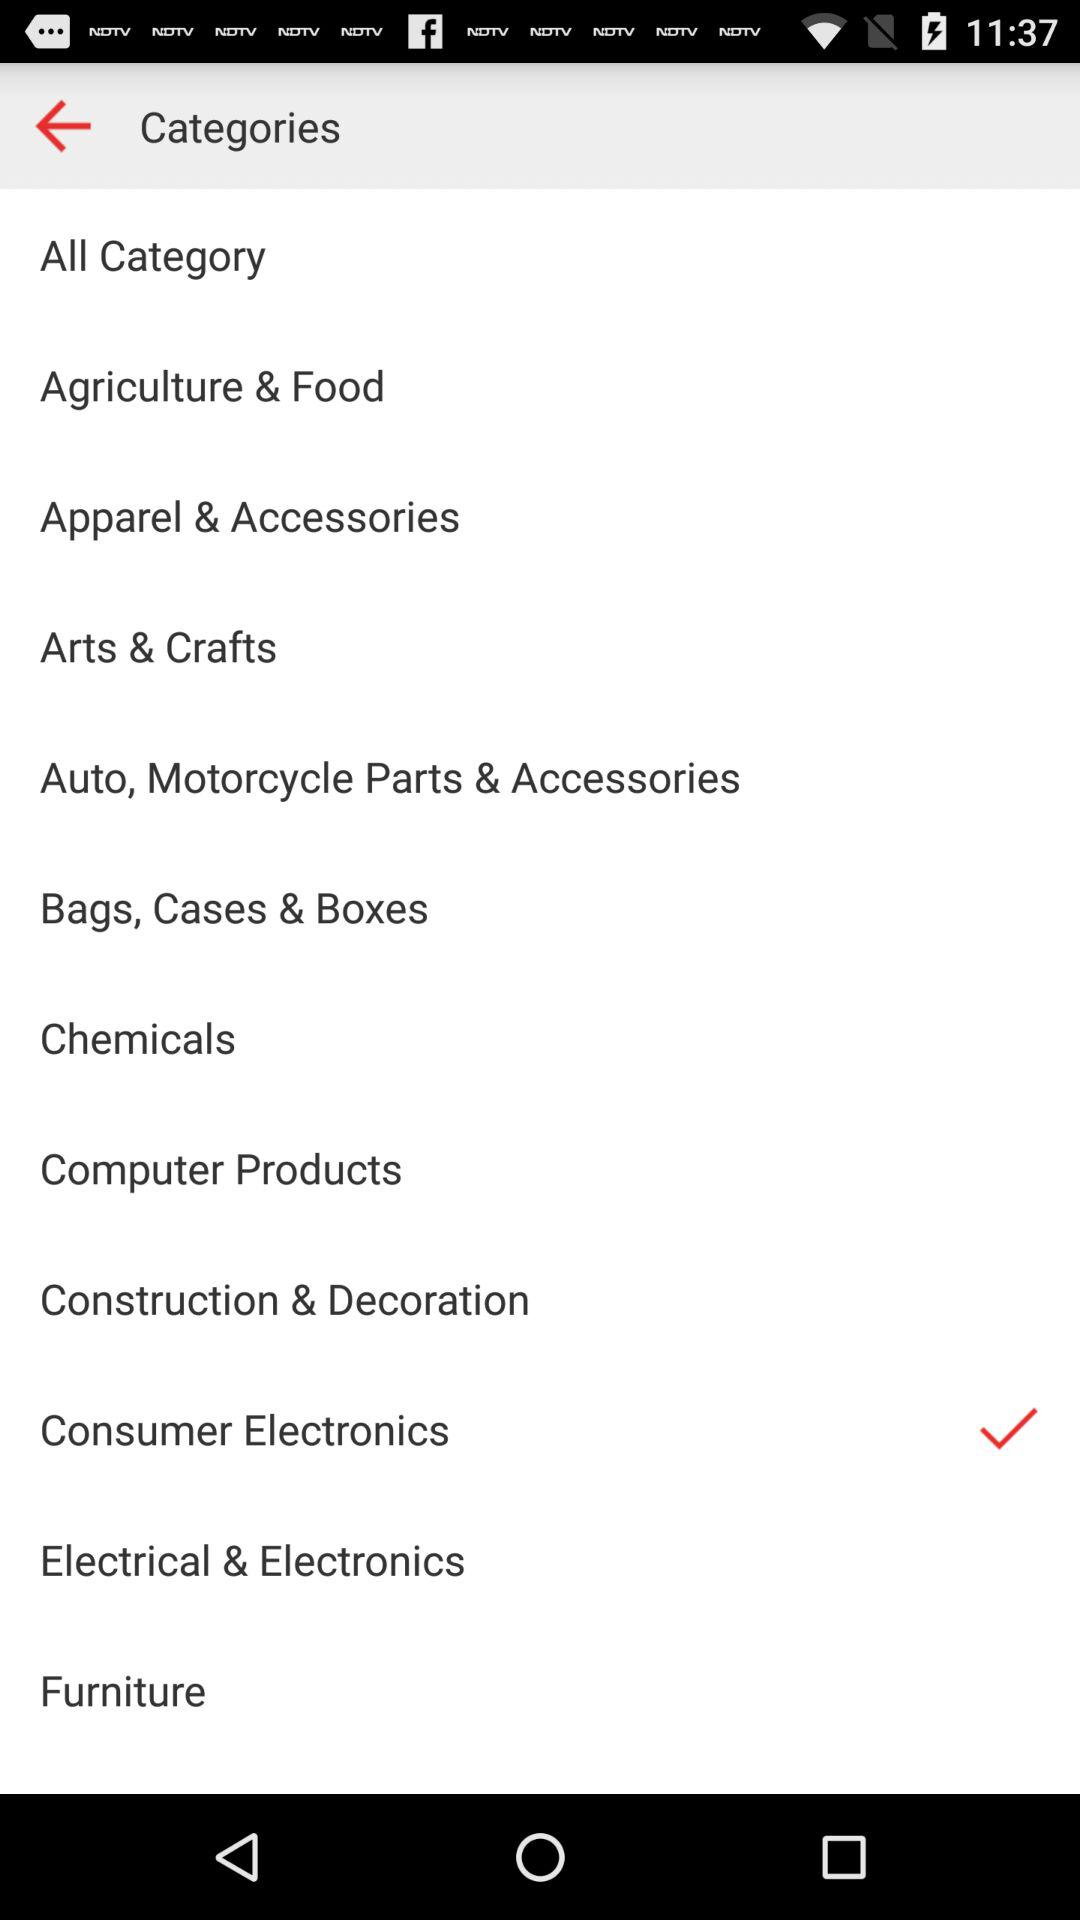What are the different displayed categories? The different displayed categories are "Agriculture & Food", "Apparel & Accessories", "Arts & Crafts", "Auto, Motorcycle Parts & Accessories", "Bags, Cases & Boxes", "Chemicals", "Computer Products", "Construction & Decoration", "Consumer Electronics", "Electrical & Electronics" and "Furniture". 